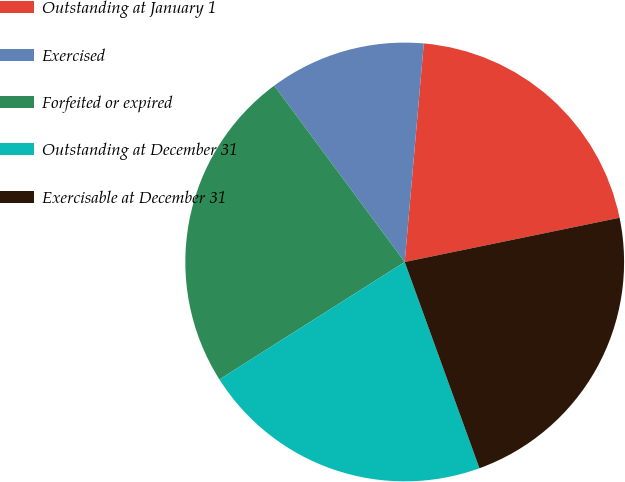Convert chart to OTSL. <chart><loc_0><loc_0><loc_500><loc_500><pie_chart><fcel>Outstanding at January 1<fcel>Exercised<fcel>Forfeited or expired<fcel>Outstanding at December 31<fcel>Exercisable at December 31<nl><fcel>20.38%<fcel>11.53%<fcel>23.85%<fcel>21.54%<fcel>22.7%<nl></chart> 